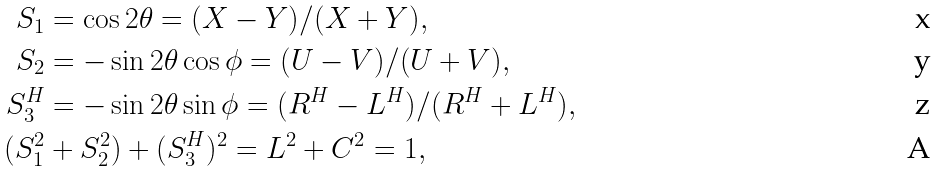Convert formula to latex. <formula><loc_0><loc_0><loc_500><loc_500>S _ { 1 } & = \cos 2 \theta = ( X - Y ) / ( X + Y ) , \\ S _ { 2 } & = - \sin 2 \theta \cos \phi = ( U - V ) / ( U + V ) , \\ S _ { 3 } ^ { H } & = - \sin 2 \theta \sin \phi = ( R ^ { H } - L ^ { H } ) / ( R ^ { H } + L ^ { H } ) , \\ ( S _ { 1 } ^ { 2 } & + S _ { 2 } ^ { 2 } ) + ( S _ { 3 } ^ { H } ) ^ { 2 } = L ^ { 2 } + C ^ { 2 } = 1 ,</formula> 